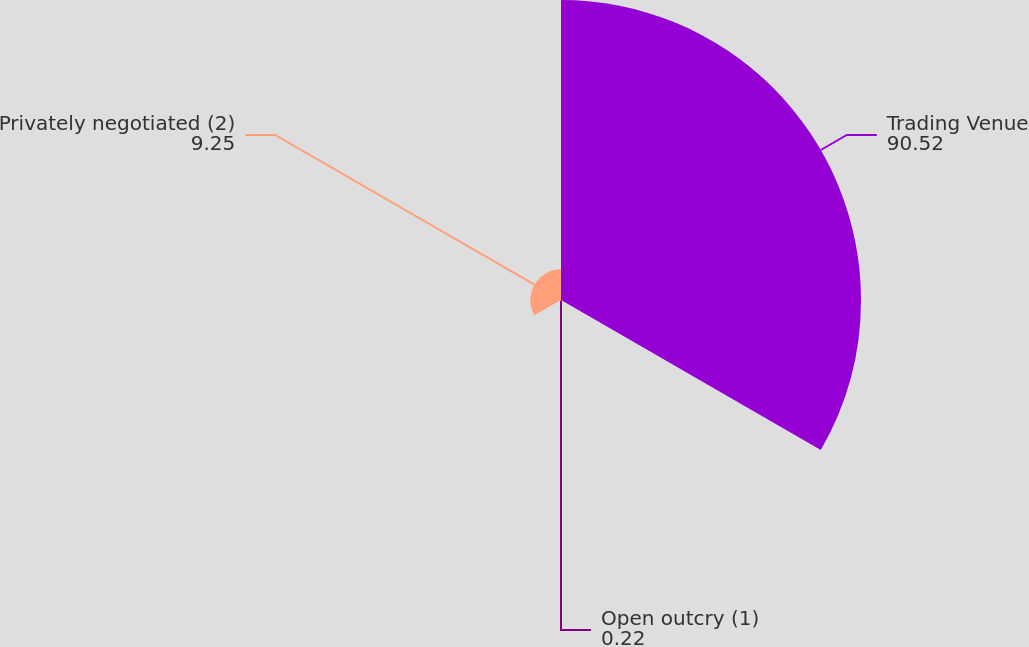Convert chart to OTSL. <chart><loc_0><loc_0><loc_500><loc_500><pie_chart><fcel>Trading Venue<fcel>Open outcry (1)<fcel>Privately negotiated (2)<nl><fcel>90.52%<fcel>0.22%<fcel>9.25%<nl></chart> 